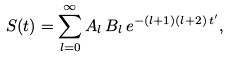Convert formula to latex. <formula><loc_0><loc_0><loc_500><loc_500>S ( t ) = \sum _ { l = 0 } ^ { \infty } A _ { l } \, B _ { l } \, e ^ { - ( l + 1 ) ( l + 2 ) \, t ^ { \prime } } ,</formula> 